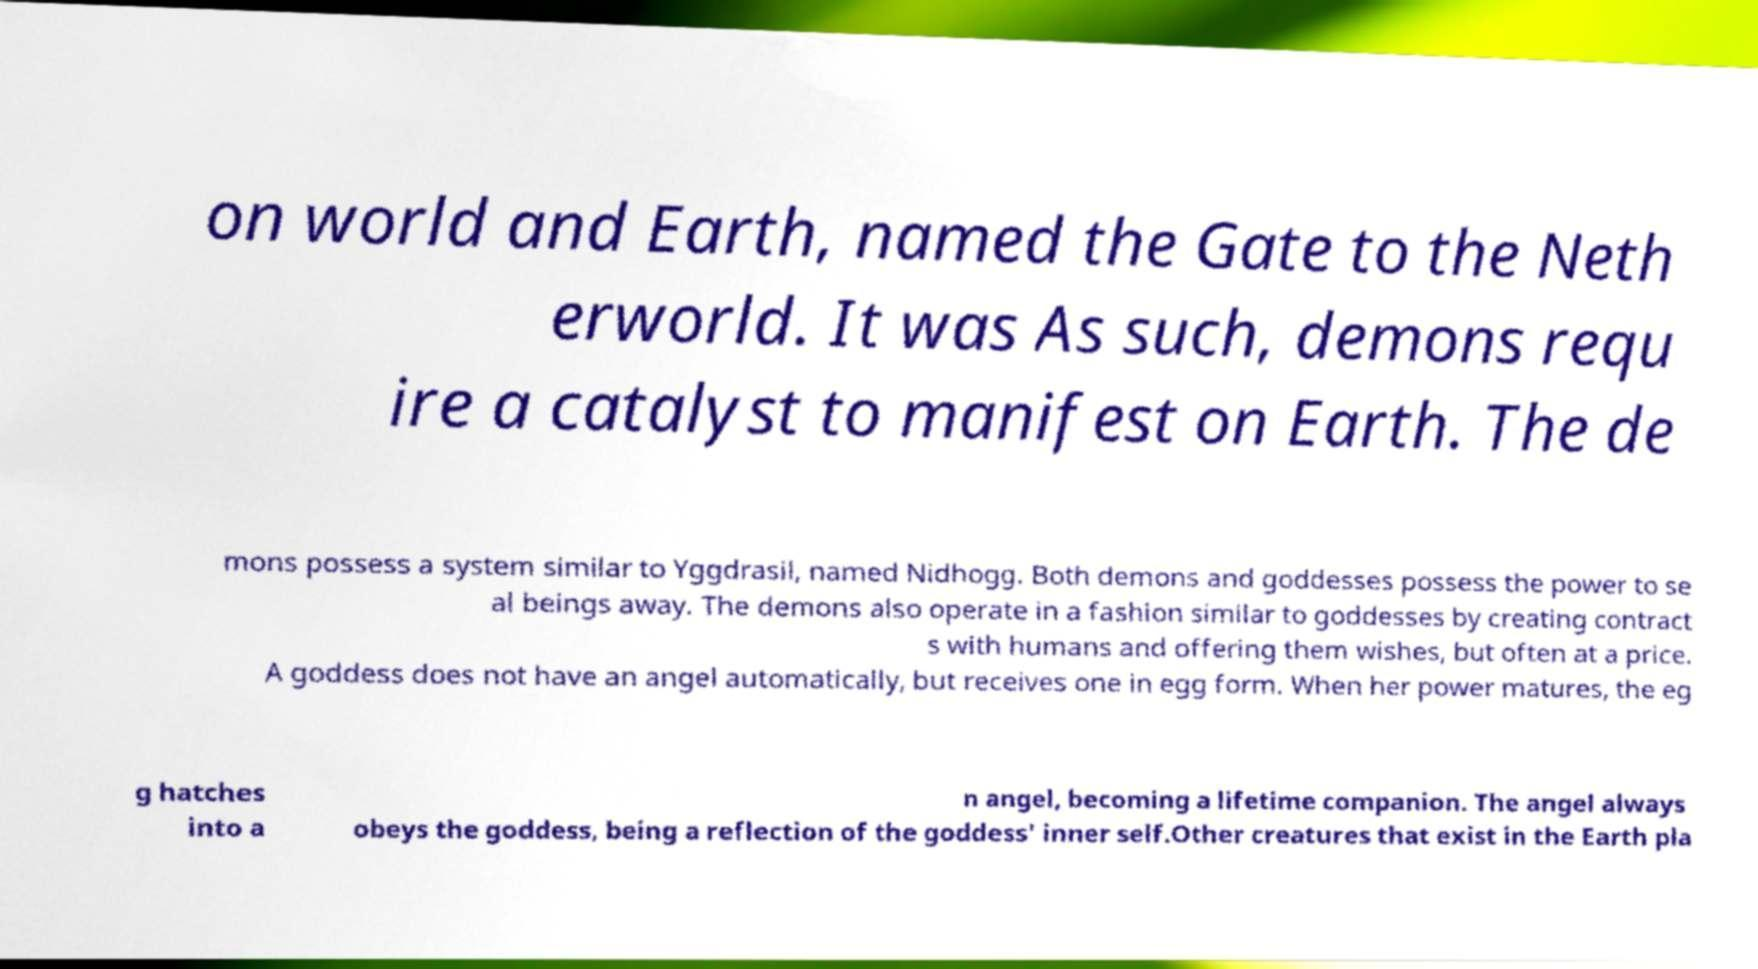Can you read and provide the text displayed in the image?This photo seems to have some interesting text. Can you extract and type it out for me? on world and Earth, named the Gate to the Neth erworld. It was As such, demons requ ire a catalyst to manifest on Earth. The de mons possess a system similar to Yggdrasil, named Nidhogg. Both demons and goddesses possess the power to se al beings away. The demons also operate in a fashion similar to goddesses by creating contract s with humans and offering them wishes, but often at a price. A goddess does not have an angel automatically, but receives one in egg form. When her power matures, the eg g hatches into a n angel, becoming a lifetime companion. The angel always obeys the goddess, being a reflection of the goddess' inner self.Other creatures that exist in the Earth pla 